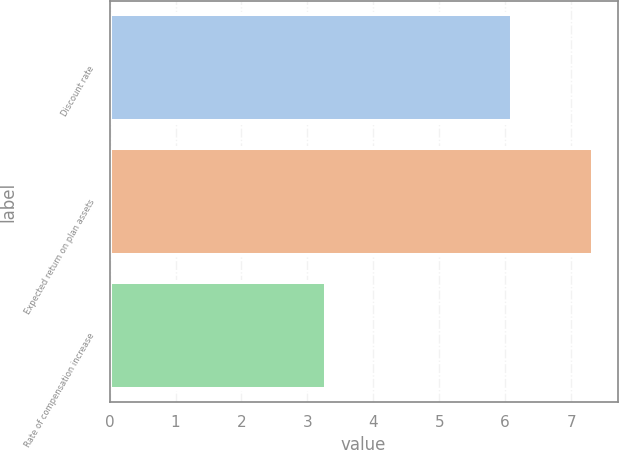Convert chart to OTSL. <chart><loc_0><loc_0><loc_500><loc_500><bar_chart><fcel>Discount rate<fcel>Expected return on plan assets<fcel>Rate of compensation increase<nl><fcel>6.11<fcel>7.34<fcel>3.28<nl></chart> 